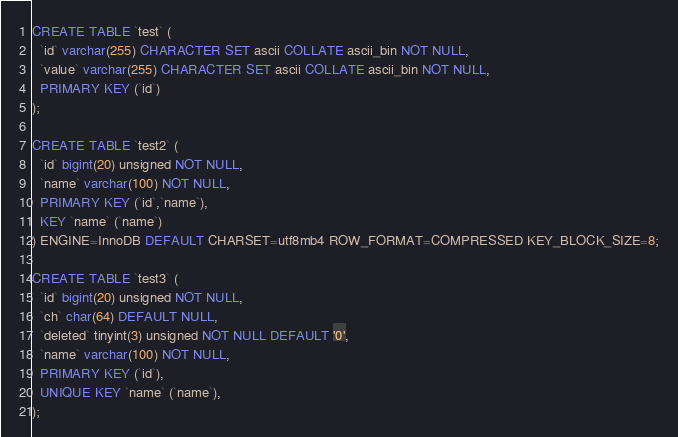<code> <loc_0><loc_0><loc_500><loc_500><_SQL_>CREATE TABLE `test` (
  `id` varchar(255) CHARACTER SET ascii COLLATE ascii_bin NOT NULL,
  `value` varchar(255) CHARACTER SET ascii COLLATE ascii_bin NOT NULL,
  PRIMARY KEY (`id`)
);

CREATE TABLE `test2` (
  `id` bigint(20) unsigned NOT NULL,
  `name` varchar(100) NOT NULL,
  PRIMARY KEY (`id`,`name`),
  KEY `name` (`name`)
) ENGINE=InnoDB DEFAULT CHARSET=utf8mb4 ROW_FORMAT=COMPRESSED KEY_BLOCK_SIZE=8;

CREATE TABLE `test3` (
  `id` bigint(20) unsigned NOT NULL,
  `ch` char(64) DEFAULT NULL,
  `deleted` tinyint(3) unsigned NOT NULL DEFAULT '0',
  `name` varchar(100) NOT NULL,
  PRIMARY KEY (`id`),
  UNIQUE KEY `name` (`name`),
);
</code> 